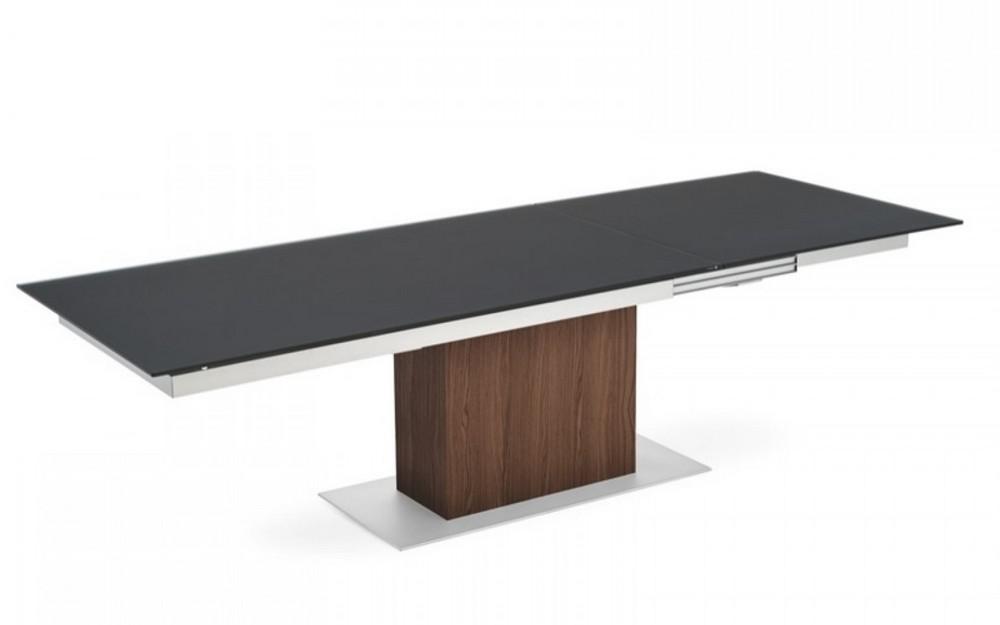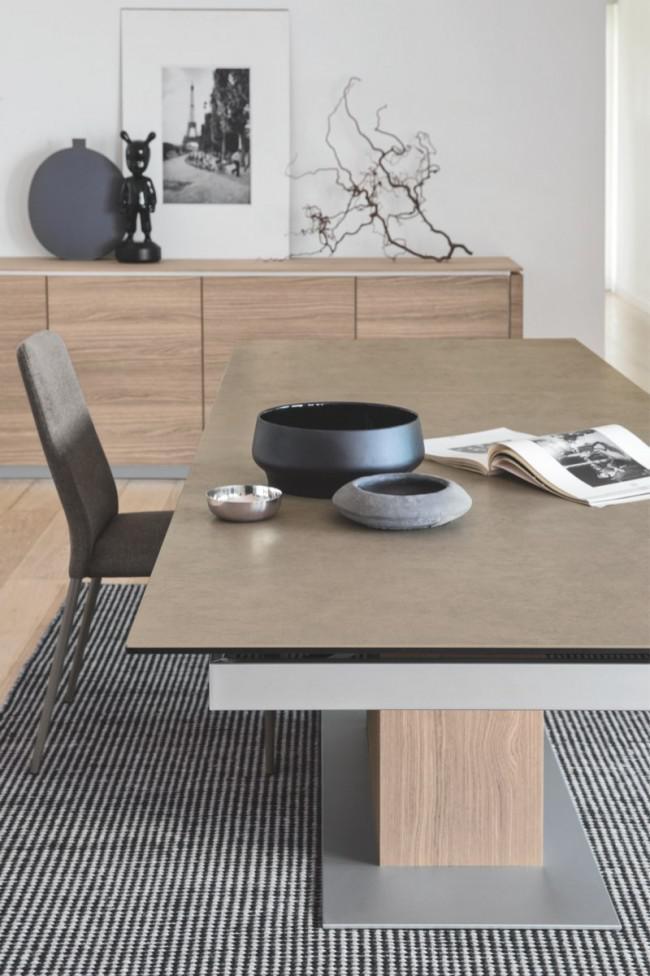The first image is the image on the left, the second image is the image on the right. Given the left and right images, does the statement "One image shows two white chairs with criss-crossed backs at a light wood table with X-shaped legs, and the other image shows a dark-topped rectangular table with a rectangular pedestal base." hold true? Answer yes or no. No. The first image is the image on the left, the second image is the image on the right. For the images displayed, is the sentence "The legs on the table in one of the images is shaped like the letter """"x""""." factually correct? Answer yes or no. No. 